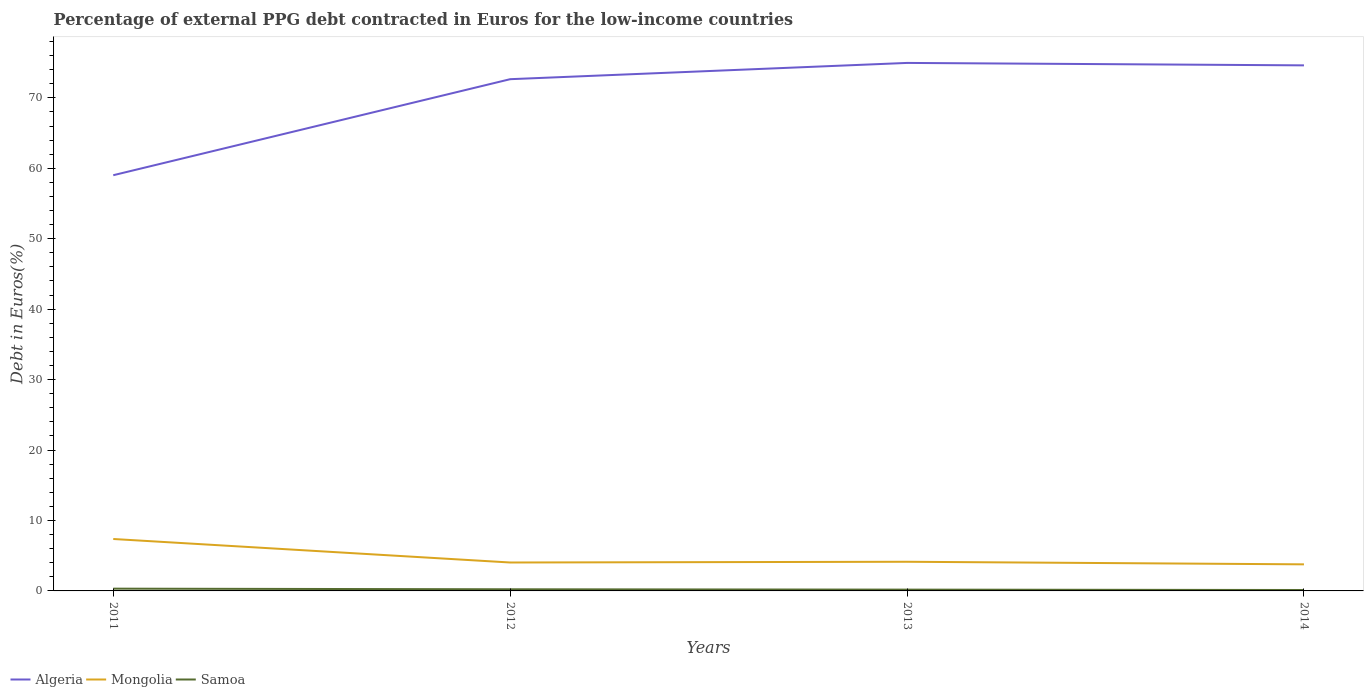Does the line corresponding to Samoa intersect with the line corresponding to Algeria?
Offer a terse response. No. Across all years, what is the maximum percentage of external PPG debt contracted in Euros in Mongolia?
Provide a succinct answer. 3.77. In which year was the percentage of external PPG debt contracted in Euros in Mongolia maximum?
Provide a succinct answer. 2014. What is the total percentage of external PPG debt contracted in Euros in Samoa in the graph?
Provide a short and direct response. 0.14. What is the difference between the highest and the second highest percentage of external PPG debt contracted in Euros in Algeria?
Your answer should be compact. 15.94. What is the difference between the highest and the lowest percentage of external PPG debt contracted in Euros in Algeria?
Make the answer very short. 3. Is the percentage of external PPG debt contracted in Euros in Samoa strictly greater than the percentage of external PPG debt contracted in Euros in Mongolia over the years?
Your answer should be very brief. Yes. What is the difference between two consecutive major ticks on the Y-axis?
Offer a very short reply. 10. Are the values on the major ticks of Y-axis written in scientific E-notation?
Make the answer very short. No. How are the legend labels stacked?
Ensure brevity in your answer.  Horizontal. What is the title of the graph?
Offer a terse response. Percentage of external PPG debt contracted in Euros for the low-income countries. What is the label or title of the X-axis?
Provide a succinct answer. Years. What is the label or title of the Y-axis?
Your response must be concise. Debt in Euros(%). What is the Debt in Euros(%) in Algeria in 2011?
Provide a short and direct response. 59.01. What is the Debt in Euros(%) in Mongolia in 2011?
Provide a succinct answer. 7.37. What is the Debt in Euros(%) in Samoa in 2011?
Ensure brevity in your answer.  0.32. What is the Debt in Euros(%) of Algeria in 2012?
Your answer should be very brief. 72.64. What is the Debt in Euros(%) of Mongolia in 2012?
Make the answer very short. 4.04. What is the Debt in Euros(%) in Samoa in 2012?
Your response must be concise. 0.23. What is the Debt in Euros(%) of Algeria in 2013?
Your answer should be very brief. 74.95. What is the Debt in Euros(%) of Mongolia in 2013?
Provide a short and direct response. 4.14. What is the Debt in Euros(%) in Samoa in 2013?
Keep it short and to the point. 0.18. What is the Debt in Euros(%) of Algeria in 2014?
Give a very brief answer. 74.61. What is the Debt in Euros(%) in Mongolia in 2014?
Make the answer very short. 3.77. What is the Debt in Euros(%) of Samoa in 2014?
Provide a succinct answer. 0.13. Across all years, what is the maximum Debt in Euros(%) of Algeria?
Provide a short and direct response. 74.95. Across all years, what is the maximum Debt in Euros(%) of Mongolia?
Offer a very short reply. 7.37. Across all years, what is the maximum Debt in Euros(%) in Samoa?
Provide a short and direct response. 0.32. Across all years, what is the minimum Debt in Euros(%) of Algeria?
Offer a terse response. 59.01. Across all years, what is the minimum Debt in Euros(%) in Mongolia?
Your answer should be very brief. 3.77. Across all years, what is the minimum Debt in Euros(%) of Samoa?
Give a very brief answer. 0.13. What is the total Debt in Euros(%) in Algeria in the graph?
Offer a terse response. 281.22. What is the total Debt in Euros(%) of Mongolia in the graph?
Your answer should be compact. 19.32. What is the total Debt in Euros(%) in Samoa in the graph?
Your answer should be very brief. 0.87. What is the difference between the Debt in Euros(%) of Algeria in 2011 and that in 2012?
Provide a short and direct response. -13.63. What is the difference between the Debt in Euros(%) in Mongolia in 2011 and that in 2012?
Ensure brevity in your answer.  3.34. What is the difference between the Debt in Euros(%) of Samoa in 2011 and that in 2012?
Provide a succinct answer. 0.09. What is the difference between the Debt in Euros(%) of Algeria in 2011 and that in 2013?
Offer a terse response. -15.94. What is the difference between the Debt in Euros(%) in Mongolia in 2011 and that in 2013?
Your answer should be very brief. 3.23. What is the difference between the Debt in Euros(%) in Samoa in 2011 and that in 2013?
Ensure brevity in your answer.  0.14. What is the difference between the Debt in Euros(%) in Algeria in 2011 and that in 2014?
Make the answer very short. -15.6. What is the difference between the Debt in Euros(%) of Mongolia in 2011 and that in 2014?
Your response must be concise. 3.6. What is the difference between the Debt in Euros(%) in Samoa in 2011 and that in 2014?
Make the answer very short. 0.19. What is the difference between the Debt in Euros(%) in Algeria in 2012 and that in 2013?
Offer a terse response. -2.31. What is the difference between the Debt in Euros(%) in Mongolia in 2012 and that in 2013?
Offer a terse response. -0.1. What is the difference between the Debt in Euros(%) of Samoa in 2012 and that in 2013?
Make the answer very short. 0.05. What is the difference between the Debt in Euros(%) in Algeria in 2012 and that in 2014?
Provide a succinct answer. -1.96. What is the difference between the Debt in Euros(%) in Mongolia in 2012 and that in 2014?
Your answer should be compact. 0.26. What is the difference between the Debt in Euros(%) in Samoa in 2012 and that in 2014?
Provide a succinct answer. 0.1. What is the difference between the Debt in Euros(%) in Algeria in 2013 and that in 2014?
Offer a terse response. 0.34. What is the difference between the Debt in Euros(%) of Mongolia in 2013 and that in 2014?
Offer a terse response. 0.37. What is the difference between the Debt in Euros(%) in Samoa in 2013 and that in 2014?
Keep it short and to the point. 0.05. What is the difference between the Debt in Euros(%) in Algeria in 2011 and the Debt in Euros(%) in Mongolia in 2012?
Provide a short and direct response. 54.98. What is the difference between the Debt in Euros(%) in Algeria in 2011 and the Debt in Euros(%) in Samoa in 2012?
Offer a very short reply. 58.78. What is the difference between the Debt in Euros(%) of Mongolia in 2011 and the Debt in Euros(%) of Samoa in 2012?
Provide a succinct answer. 7.14. What is the difference between the Debt in Euros(%) of Algeria in 2011 and the Debt in Euros(%) of Mongolia in 2013?
Make the answer very short. 54.87. What is the difference between the Debt in Euros(%) of Algeria in 2011 and the Debt in Euros(%) of Samoa in 2013?
Provide a short and direct response. 58.83. What is the difference between the Debt in Euros(%) in Mongolia in 2011 and the Debt in Euros(%) in Samoa in 2013?
Offer a terse response. 7.19. What is the difference between the Debt in Euros(%) in Algeria in 2011 and the Debt in Euros(%) in Mongolia in 2014?
Keep it short and to the point. 55.24. What is the difference between the Debt in Euros(%) in Algeria in 2011 and the Debt in Euros(%) in Samoa in 2014?
Offer a very short reply. 58.88. What is the difference between the Debt in Euros(%) of Mongolia in 2011 and the Debt in Euros(%) of Samoa in 2014?
Offer a very short reply. 7.24. What is the difference between the Debt in Euros(%) in Algeria in 2012 and the Debt in Euros(%) in Mongolia in 2013?
Offer a very short reply. 68.5. What is the difference between the Debt in Euros(%) in Algeria in 2012 and the Debt in Euros(%) in Samoa in 2013?
Give a very brief answer. 72.46. What is the difference between the Debt in Euros(%) of Mongolia in 2012 and the Debt in Euros(%) of Samoa in 2013?
Your answer should be very brief. 3.85. What is the difference between the Debt in Euros(%) in Algeria in 2012 and the Debt in Euros(%) in Mongolia in 2014?
Offer a terse response. 68.87. What is the difference between the Debt in Euros(%) in Algeria in 2012 and the Debt in Euros(%) in Samoa in 2014?
Your answer should be very brief. 72.51. What is the difference between the Debt in Euros(%) of Mongolia in 2012 and the Debt in Euros(%) of Samoa in 2014?
Ensure brevity in your answer.  3.9. What is the difference between the Debt in Euros(%) of Algeria in 2013 and the Debt in Euros(%) of Mongolia in 2014?
Your answer should be very brief. 71.18. What is the difference between the Debt in Euros(%) of Algeria in 2013 and the Debt in Euros(%) of Samoa in 2014?
Make the answer very short. 74.82. What is the difference between the Debt in Euros(%) in Mongolia in 2013 and the Debt in Euros(%) in Samoa in 2014?
Provide a short and direct response. 4.01. What is the average Debt in Euros(%) in Algeria per year?
Ensure brevity in your answer.  70.31. What is the average Debt in Euros(%) of Mongolia per year?
Make the answer very short. 4.83. What is the average Debt in Euros(%) of Samoa per year?
Make the answer very short. 0.22. In the year 2011, what is the difference between the Debt in Euros(%) of Algeria and Debt in Euros(%) of Mongolia?
Give a very brief answer. 51.64. In the year 2011, what is the difference between the Debt in Euros(%) in Algeria and Debt in Euros(%) in Samoa?
Offer a terse response. 58.69. In the year 2011, what is the difference between the Debt in Euros(%) of Mongolia and Debt in Euros(%) of Samoa?
Give a very brief answer. 7.05. In the year 2012, what is the difference between the Debt in Euros(%) in Algeria and Debt in Euros(%) in Mongolia?
Offer a terse response. 68.61. In the year 2012, what is the difference between the Debt in Euros(%) in Algeria and Debt in Euros(%) in Samoa?
Give a very brief answer. 72.41. In the year 2012, what is the difference between the Debt in Euros(%) of Mongolia and Debt in Euros(%) of Samoa?
Ensure brevity in your answer.  3.8. In the year 2013, what is the difference between the Debt in Euros(%) in Algeria and Debt in Euros(%) in Mongolia?
Provide a succinct answer. 70.81. In the year 2013, what is the difference between the Debt in Euros(%) of Algeria and Debt in Euros(%) of Samoa?
Your answer should be compact. 74.77. In the year 2013, what is the difference between the Debt in Euros(%) in Mongolia and Debt in Euros(%) in Samoa?
Give a very brief answer. 3.96. In the year 2014, what is the difference between the Debt in Euros(%) of Algeria and Debt in Euros(%) of Mongolia?
Provide a short and direct response. 70.84. In the year 2014, what is the difference between the Debt in Euros(%) in Algeria and Debt in Euros(%) in Samoa?
Give a very brief answer. 74.48. In the year 2014, what is the difference between the Debt in Euros(%) of Mongolia and Debt in Euros(%) of Samoa?
Make the answer very short. 3.64. What is the ratio of the Debt in Euros(%) of Algeria in 2011 to that in 2012?
Keep it short and to the point. 0.81. What is the ratio of the Debt in Euros(%) in Mongolia in 2011 to that in 2012?
Provide a short and direct response. 1.83. What is the ratio of the Debt in Euros(%) of Samoa in 2011 to that in 2012?
Provide a succinct answer. 1.38. What is the ratio of the Debt in Euros(%) in Algeria in 2011 to that in 2013?
Offer a terse response. 0.79. What is the ratio of the Debt in Euros(%) of Mongolia in 2011 to that in 2013?
Keep it short and to the point. 1.78. What is the ratio of the Debt in Euros(%) in Samoa in 2011 to that in 2013?
Provide a succinct answer. 1.75. What is the ratio of the Debt in Euros(%) in Algeria in 2011 to that in 2014?
Your answer should be very brief. 0.79. What is the ratio of the Debt in Euros(%) in Mongolia in 2011 to that in 2014?
Offer a very short reply. 1.95. What is the ratio of the Debt in Euros(%) in Samoa in 2011 to that in 2014?
Offer a terse response. 2.45. What is the ratio of the Debt in Euros(%) in Algeria in 2012 to that in 2013?
Keep it short and to the point. 0.97. What is the ratio of the Debt in Euros(%) of Mongolia in 2012 to that in 2013?
Offer a very short reply. 0.97. What is the ratio of the Debt in Euros(%) of Samoa in 2012 to that in 2013?
Your answer should be very brief. 1.27. What is the ratio of the Debt in Euros(%) in Algeria in 2012 to that in 2014?
Offer a terse response. 0.97. What is the ratio of the Debt in Euros(%) in Mongolia in 2012 to that in 2014?
Offer a very short reply. 1.07. What is the ratio of the Debt in Euros(%) in Samoa in 2012 to that in 2014?
Offer a very short reply. 1.77. What is the ratio of the Debt in Euros(%) in Algeria in 2013 to that in 2014?
Your answer should be compact. 1. What is the ratio of the Debt in Euros(%) in Mongolia in 2013 to that in 2014?
Give a very brief answer. 1.1. What is the ratio of the Debt in Euros(%) in Samoa in 2013 to that in 2014?
Give a very brief answer. 1.4. What is the difference between the highest and the second highest Debt in Euros(%) in Algeria?
Your answer should be very brief. 0.34. What is the difference between the highest and the second highest Debt in Euros(%) of Mongolia?
Ensure brevity in your answer.  3.23. What is the difference between the highest and the second highest Debt in Euros(%) in Samoa?
Make the answer very short. 0.09. What is the difference between the highest and the lowest Debt in Euros(%) of Algeria?
Your answer should be compact. 15.94. What is the difference between the highest and the lowest Debt in Euros(%) in Mongolia?
Your answer should be very brief. 3.6. What is the difference between the highest and the lowest Debt in Euros(%) in Samoa?
Offer a very short reply. 0.19. 